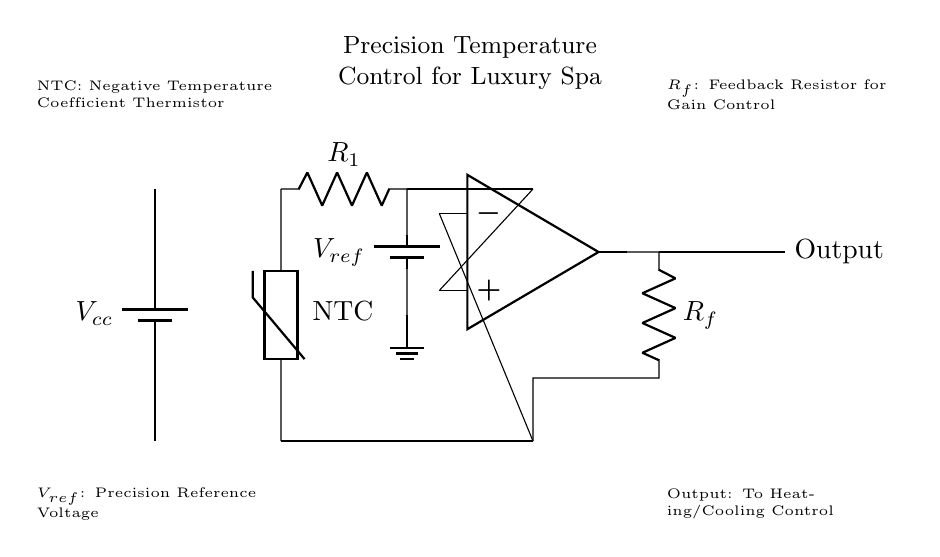What is the type of thermistor used in this circuit? The diagram indicates that the thermistor is labeled "NTC," which stands for Negative Temperature Coefficient. This means its resistance decreases as the temperature increases.
Answer: NTC What is the purpose of the feedback resistor in this circuit? The feedback resistor, labeled as "Rf," influences the gain of the operational amplifier. By varying "Rf," you can adjust how much the output voltage responds to changes in the input voltage provided by the thermistor.
Answer: Gain control What is the reference voltage in this circuit? The diagram shows a reference voltage labeled "Vref" connected to a ground and the voltage divider configuration. It serves as the baseline against which the thermistor's voltage is compared.
Answer: Vref How many op-amps are present in the circuit? The diagram clearly illustrates a single operational amplifier symbol depicted in the center. It shows that this circuit uses one op-amp to process the input signals.
Answer: One What does the output of the op-amp control? The output from the operational amplifier is directed to a component labeled "Output," which indicates that it is responsible for controlling the heating or cooling system based on the temperature readings from the thermistor.
Answer: Heating/Cooling control What happens to the voltage from the thermistor as temperature increases? As the temperature rises, the resistance of the NTC thermistor decreases, resulting in a corresponding increase in voltage at the input of the op-amp. This behavior is critical for accurate temperature control in the luxury spa scenario.
Answer: Voltage increases 